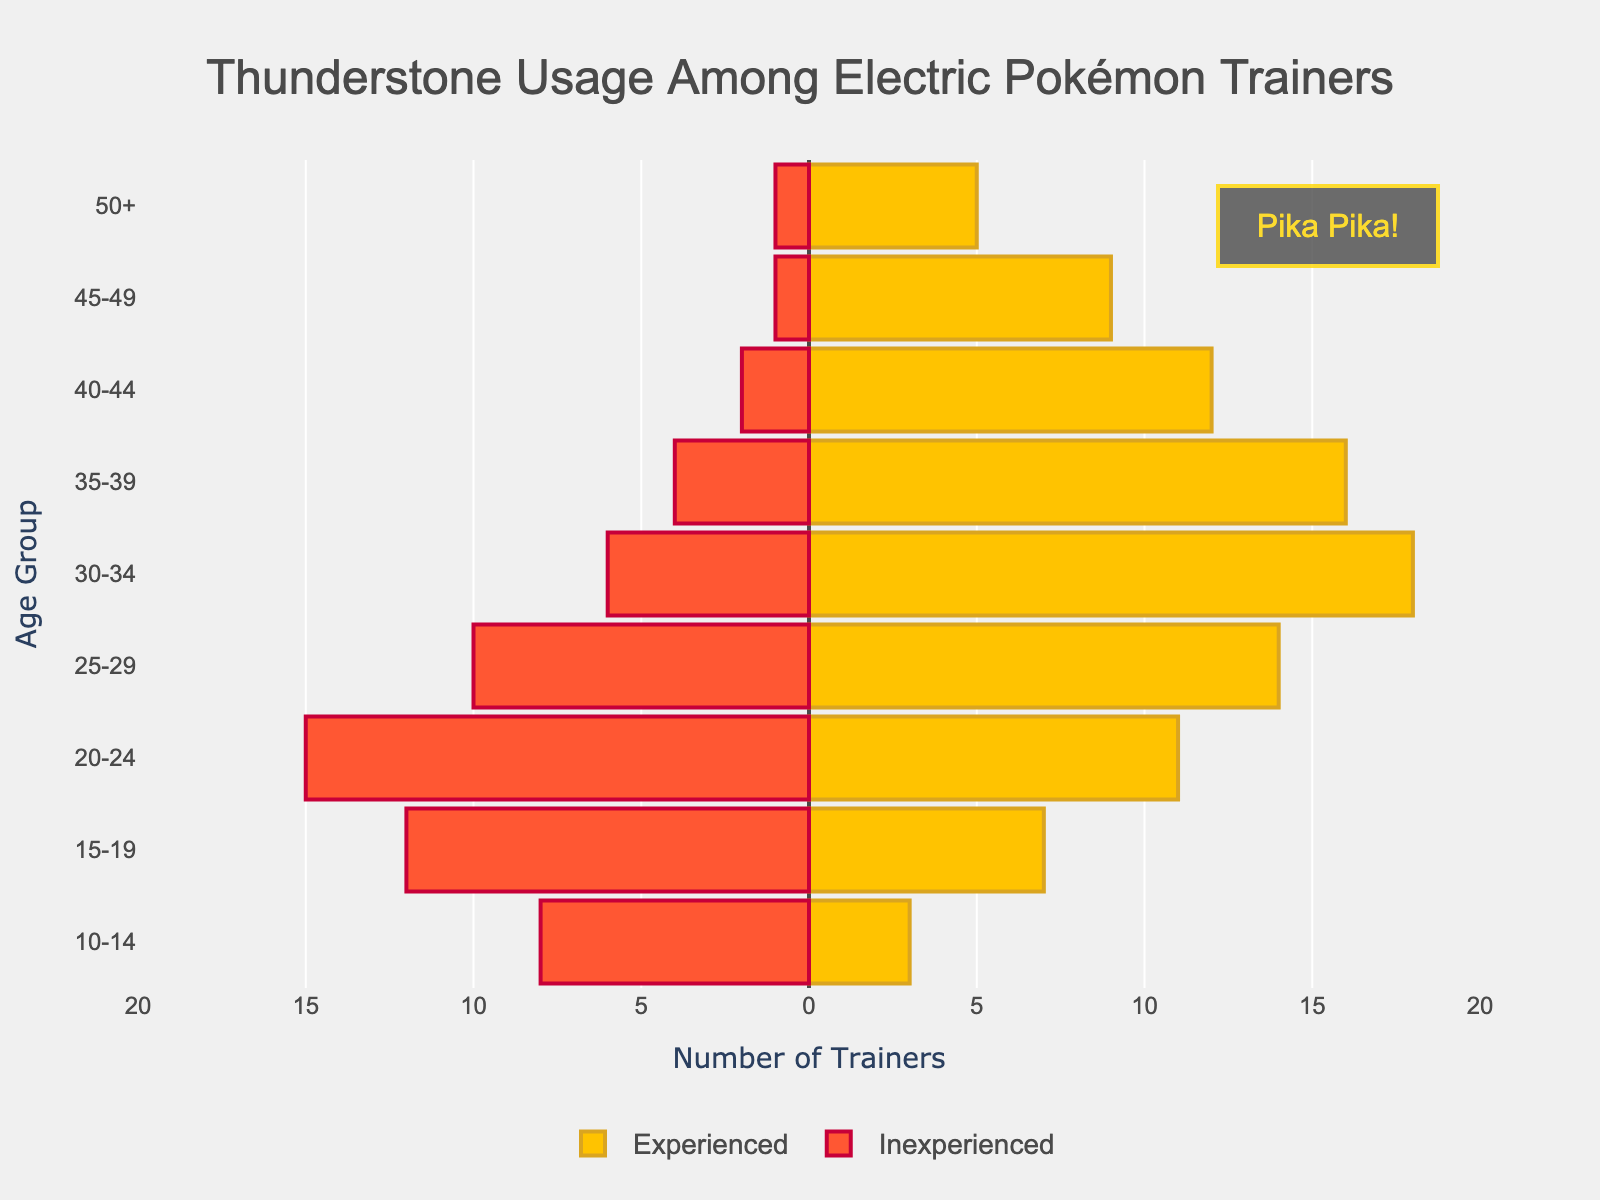What age group has the highest number of experienced trainers? Look at the bars for experienced trainers across different age groups. The '30-34' age group has the longest bar.
Answer: 30-34 What is the age group of trainers who have the lowest number of inexperienced trainers? Compare the lengths of the inexperienced trainer bars for all age groups. The '45-49' and '50+' age groups have the shortest bars representing 1 trainer each.
Answer: 45-49 and 50+ In which age group(s) is the number of inexperienced trainers almost equal to the number of experienced trainers? The difference between inexperienced and experienced trainers should be minimal. For age groups '10-14' and '45-49', sums are 8 vs 3 and 1 vs 9.
Answer: None are close enough In which age group is the difference between experienced and inexperienced trainers the highest? Calculate the difference between experienced and inexperienced trainers for each bar. '30-34' age group has the largest gap, 18 (experienced) - 6 (inexperienced) = 12.
Answer: 30-34 